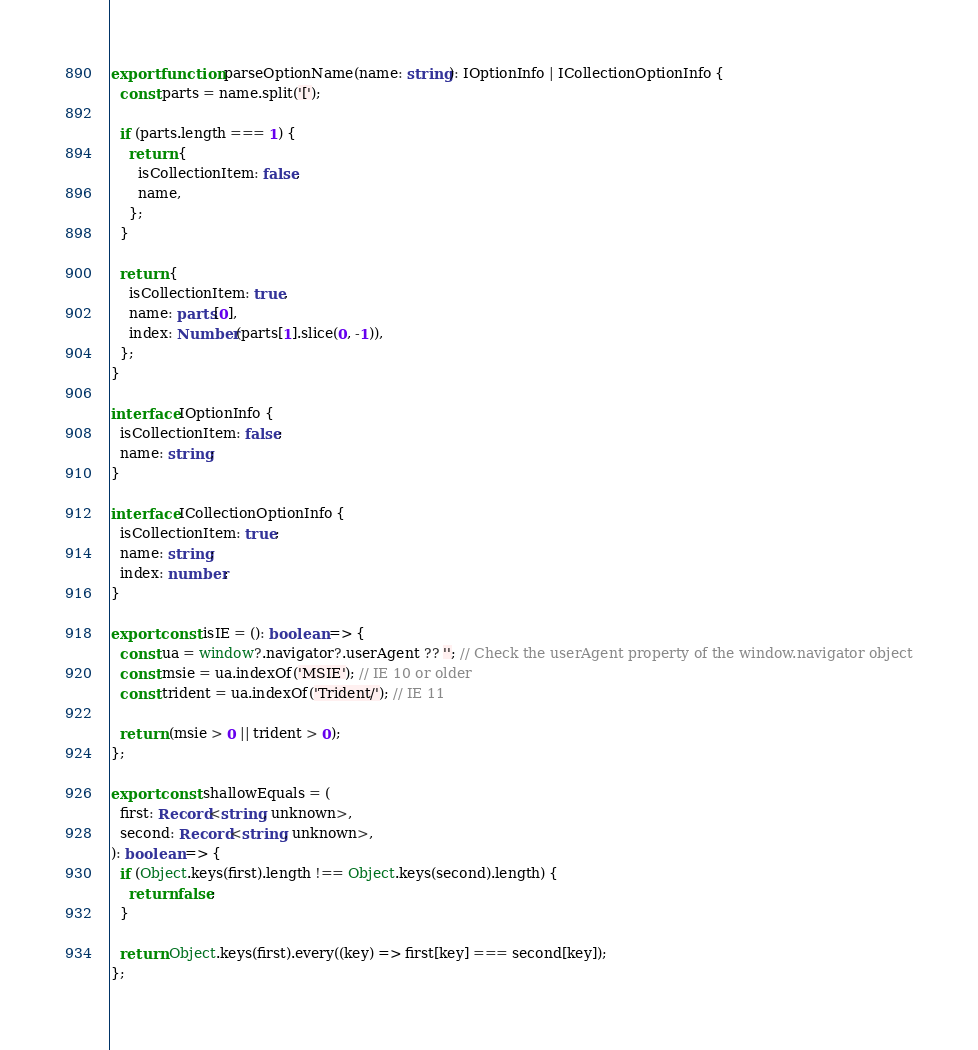<code> <loc_0><loc_0><loc_500><loc_500><_TypeScript_>export function parseOptionName(name: string): IOptionInfo | ICollectionOptionInfo {
  const parts = name.split('[');

  if (parts.length === 1) {
    return {
      isCollectionItem: false,
      name,
    };
  }

  return {
    isCollectionItem: true,
    name: parts[0],
    index: Number(parts[1].slice(0, -1)),
  };
}

interface IOptionInfo {
  isCollectionItem: false;
  name: string;
}

interface ICollectionOptionInfo {
  isCollectionItem: true;
  name: string;
  index: number;
}

export const isIE = (): boolean => {
  const ua = window?.navigator?.userAgent ?? ''; // Check the userAgent property of the window.navigator object
  const msie = ua.indexOf('MSIE'); // IE 10 or older
  const trident = ua.indexOf('Trident/'); // IE 11

  return (msie > 0 || trident > 0);
};

export const shallowEquals = (
  first: Record<string, unknown>,
  second: Record<string, unknown>,
): boolean => {
  if (Object.keys(first).length !== Object.keys(second).length) {
    return false;
  }

  return Object.keys(first).every((key) => first[key] === second[key]);
};
</code> 